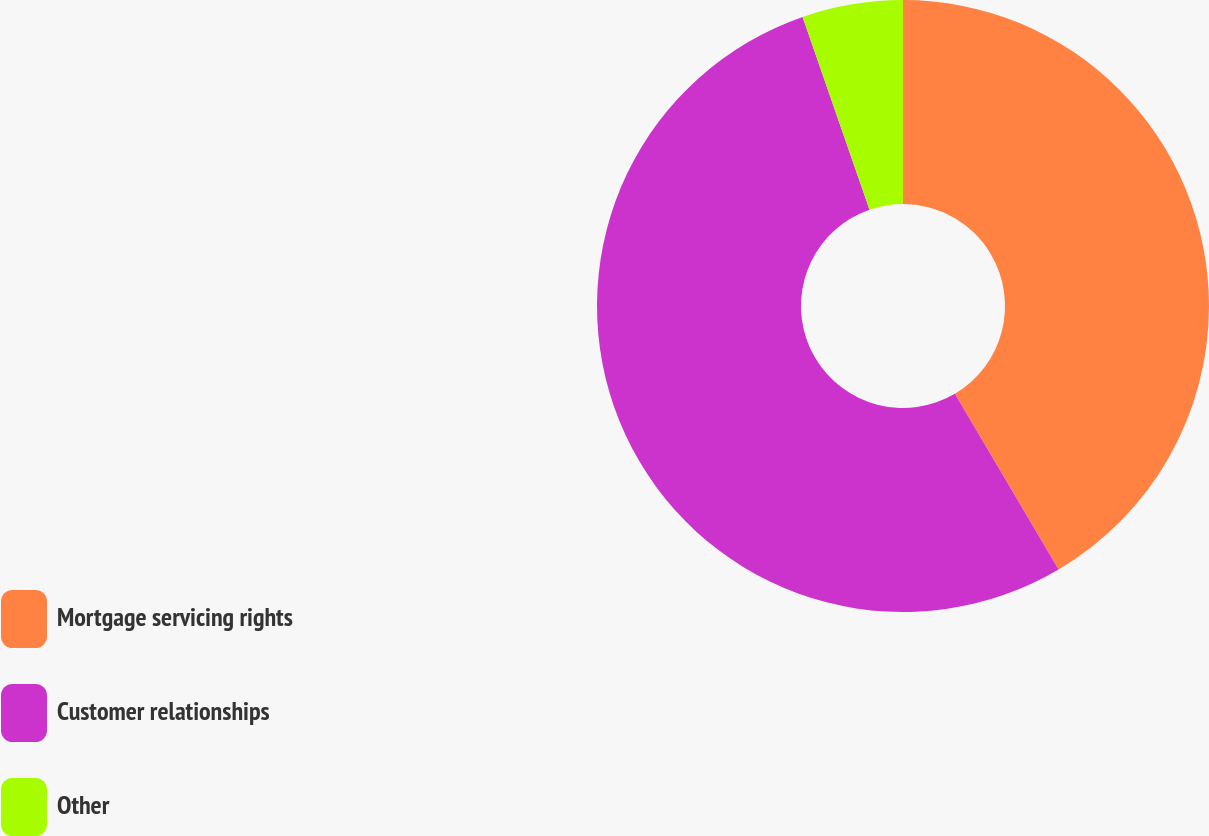Convert chart to OTSL. <chart><loc_0><loc_0><loc_500><loc_500><pie_chart><fcel>Mortgage servicing rights<fcel>Customer relationships<fcel>Other<nl><fcel>41.51%<fcel>53.17%<fcel>5.32%<nl></chart> 